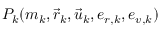<formula> <loc_0><loc_0><loc_500><loc_500>P _ { k } ( m _ { k } , { \vec { r } } _ { k } , { \vec { u } } _ { k } , e _ { r , k } , e _ { v , k } )</formula> 